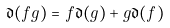<formula> <loc_0><loc_0><loc_500><loc_500>\mathfrak { d } ( f g ) = f \mathfrak { d } ( g ) + g \mathfrak { d } ( f )</formula> 